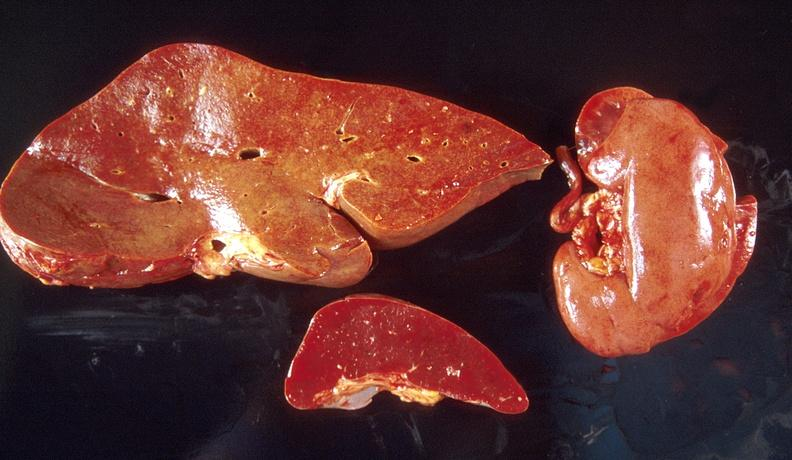does hematoma show amyloid, liver, spleen, and kidney?
Answer the question using a single word or phrase. No 